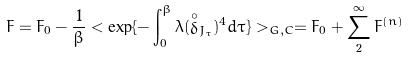Convert formula to latex. <formula><loc_0><loc_0><loc_500><loc_500>F = F _ { 0 } - { \frac { 1 } { \beta } } < \exp \{ - \int _ { 0 } ^ { \beta } \lambda ( \stackrel { \circ } { \delta } _ { J _ { \tau } } ) ^ { 4 } d \tau \} > _ { G , C } = F _ { 0 } + \sum ^ { \infty } _ { 2 } F ^ { ( n ) }</formula> 